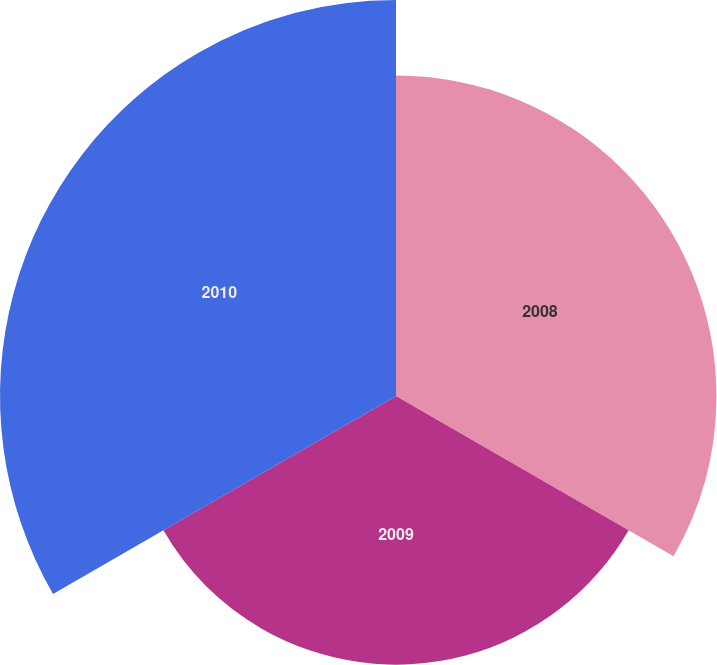Convert chart to OTSL. <chart><loc_0><loc_0><loc_500><loc_500><pie_chart><fcel>2008<fcel>2009<fcel>2010<nl><fcel>32.53%<fcel>27.27%<fcel>40.2%<nl></chart> 